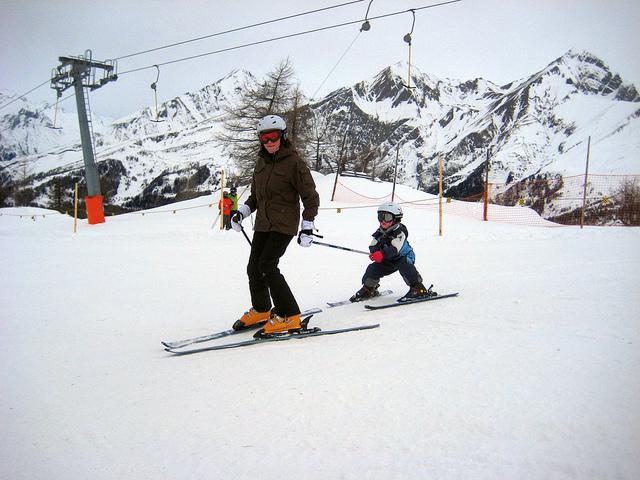What does the adult and child have on their head?
Give a very brief answer. Helmets. Why is the kid behind the adult?
Write a very short answer. Learning. What is the purpose of the tall pole in the back left?
Answer briefly. Ski lift. 